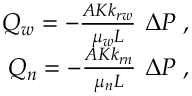Convert formula to latex. <formula><loc_0><loc_0><loc_500><loc_500>\begin{array} { r } { Q _ { w } = - \frac { A K k _ { r w } } { \mu _ { w } L } \ \Delta P \, , } \\ { Q _ { n } = - \frac { A K k _ { r n } } { \mu _ { n } L } \ \Delta P \, , } \end{array}</formula> 